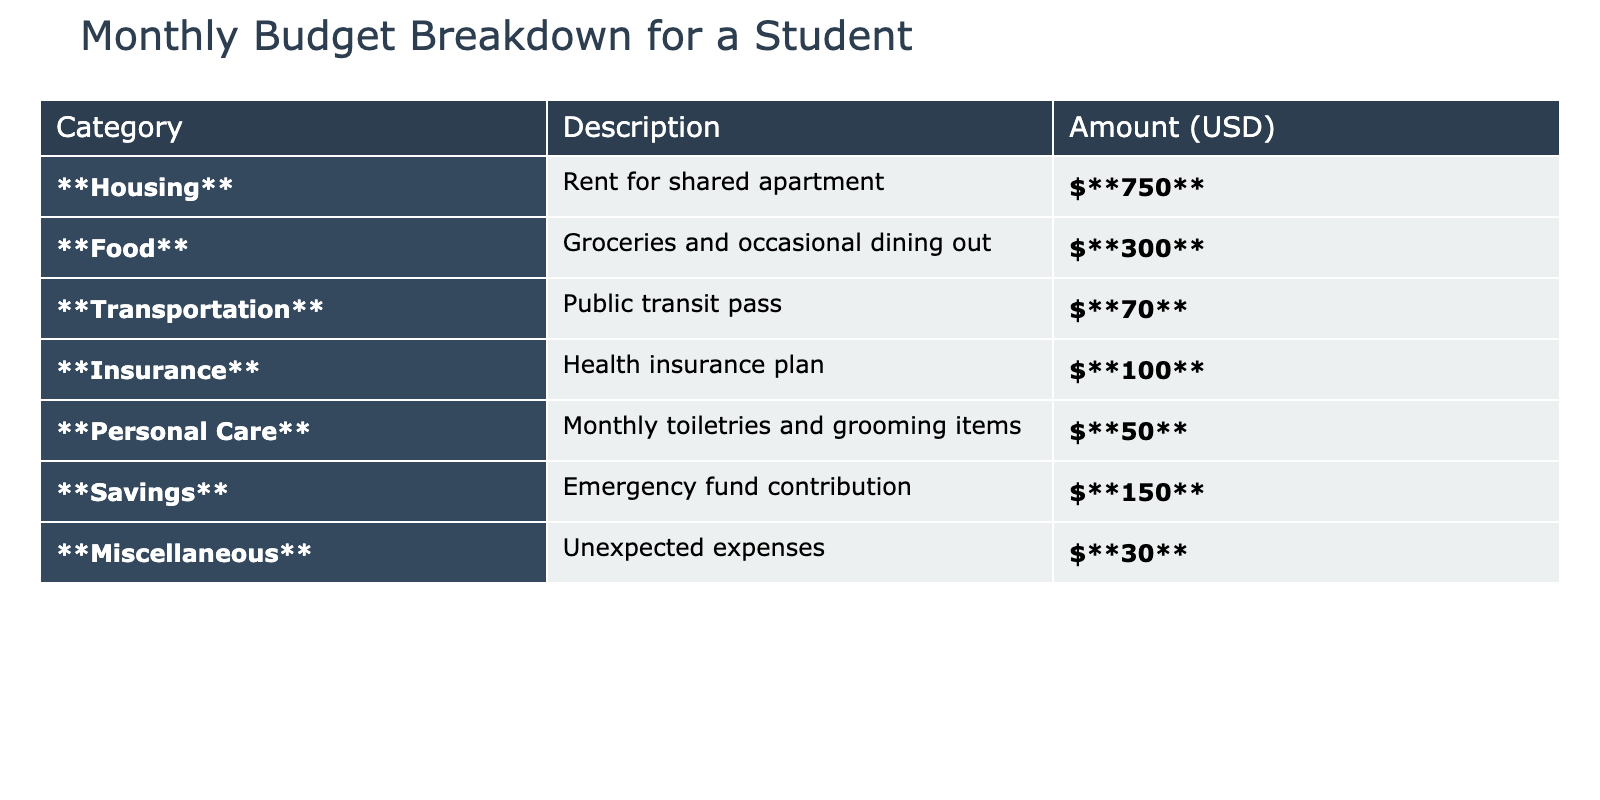What is the total amount allocated for Housing? The table shows that the amount allocated for Housing is listed as 750 USD.
Answer: 750 USD How much does the student spend on Food each month? The amount spent on Food, as indicated in the table, is 300 USD.
Answer: 300 USD What is the least amount spent in any category? Looking at the table, the least amount spent is in the Miscellaneous category, which is 30 USD.
Answer: 30 USD What is the total spending on Transportation and Insurance combined? The amount for Transportation is 70 USD and for Insurance is 100 USD. Adding these together: 70 + 100 = 170 USD.
Answer: 170 USD Is the Monthly contribution for Savings higher than the amount spent on Personal Care? The amount for Savings is 150 USD, which is higher than the Personal Care amount of 50 USD. Therefore, the statement is true.
Answer: Yes What is the total monthly budget calculated from all categories? To find the total, add each category's amount: 750 + 300 + 70 + 100 + 50 + 150 + 30 = 1450 USD, which makes up the total budget for the student.
Answer: 1450 USD What percentage of the total budget is spent on Food? First, we know the total budget is 1450 USD. Food spending is 300 USD. To find the percentage: (300 / 1450) * 100 = approximately 20.69%.
Answer: 20.69% If the student wants to increase their savings by 50 USD, what would their new Savings amount be? The current Savings amount is 150 USD. If the student wants to increase it by 50 USD, the new Savings amount would be 150 + 50 = 200 USD.
Answer: 200 USD Combining the amounts spent on Personal Care, Miscellaneous, and Transportation, what is the total? The total for these categories is calculated as: Personal Care (50 USD) + Miscellaneous (30 USD) + Transportation (70 USD) = 150 USD total.
Answer: 150 USD Is the total spending on Housing and Food greater than the total spent on Insurance and Personal Care combined? Housing (750 USD) and Food (300 USD) together total 1050 USD. Insurance (100 USD) and Personal Care (50 USD) combined total 150 USD. Since 1050 > 150, the statement is true.
Answer: Yes 